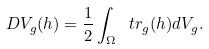<formula> <loc_0><loc_0><loc_500><loc_500>D V _ { g } ( h ) = \frac { 1 } { 2 } \int _ { \Omega } \ t r _ { g } ( h ) d V _ { g } .</formula> 